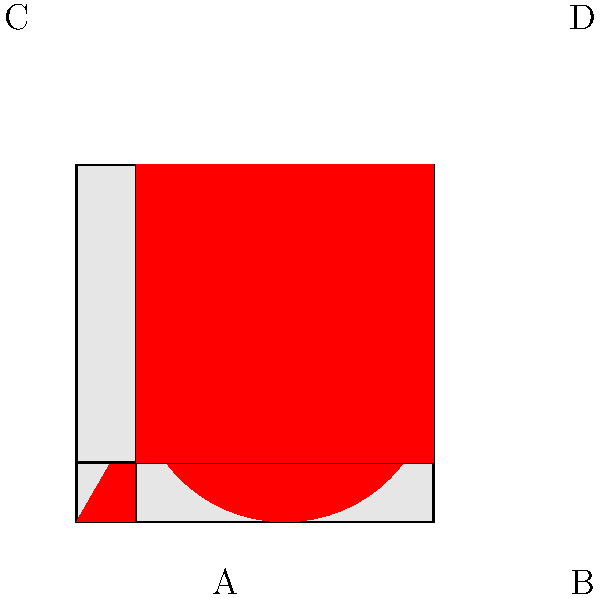As you browse through the record store's eclectic collection, you notice four uniquely designed album covers. Each cover features a distinct shape (triangle, circle, star, and square) on a light gray background. However, some of the covers appear to be rotated. Which sequence of rotations (clockwise) would correctly orient all album covers so that the shapes are in their standard positions? To solve this problem, we need to analyze each album cover and determine the rotation needed to bring it to its standard orientation. Let's go through them one by one:

1. Album A (Triangle): The triangle is already in its standard position with the base at the bottom and the point at the top. No rotation is needed.

2. Album B (Circle): The circle is rotationally symmetric, so any orientation is correct. No rotation is needed.

3. Album C (Star): The star is currently pointing to the left. To bring it to its standard orientation (pointing up), we need to rotate it 90° clockwise.

4. Album D (Square): The square appears to be upside down. To bring it to its standard orientation, we need to rotate it 180° clockwise.

Therefore, the sequence of rotations needed is:

A: 0°
B: 0°
C: 90°
D: 180°
Answer: 0°, 0°, 90°, 180° 